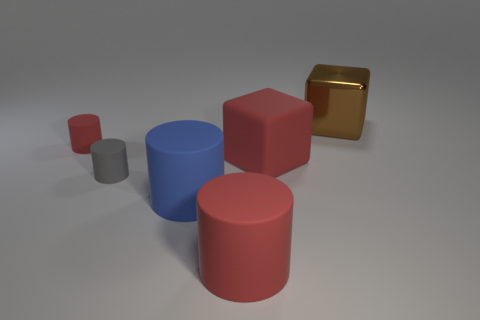Add 4 big green matte things. How many objects exist? 10 Subtract all cubes. How many objects are left? 4 Subtract all small gray objects. Subtract all matte cylinders. How many objects are left? 1 Add 4 small rubber cylinders. How many small rubber cylinders are left? 6 Add 3 matte cubes. How many matte cubes exist? 4 Subtract 0 gray spheres. How many objects are left? 6 